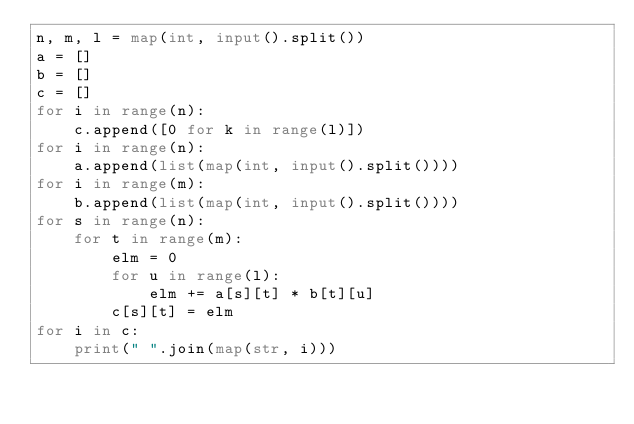Convert code to text. <code><loc_0><loc_0><loc_500><loc_500><_Python_>n, m, l = map(int, input().split())
a = []
b = []
c = []
for i in range(n):
    c.append([0 for k in range(l)])
for i in range(n):
    a.append(list(map(int, input().split())))
for i in range(m):
    b.append(list(map(int, input().split())))
for s in range(n):
    for t in range(m):
        elm = 0
        for u in range(l):
            elm += a[s][t] * b[t][u]
        c[s][t] = elm
for i in c:
    print(" ".join(map(str, i)))
</code> 